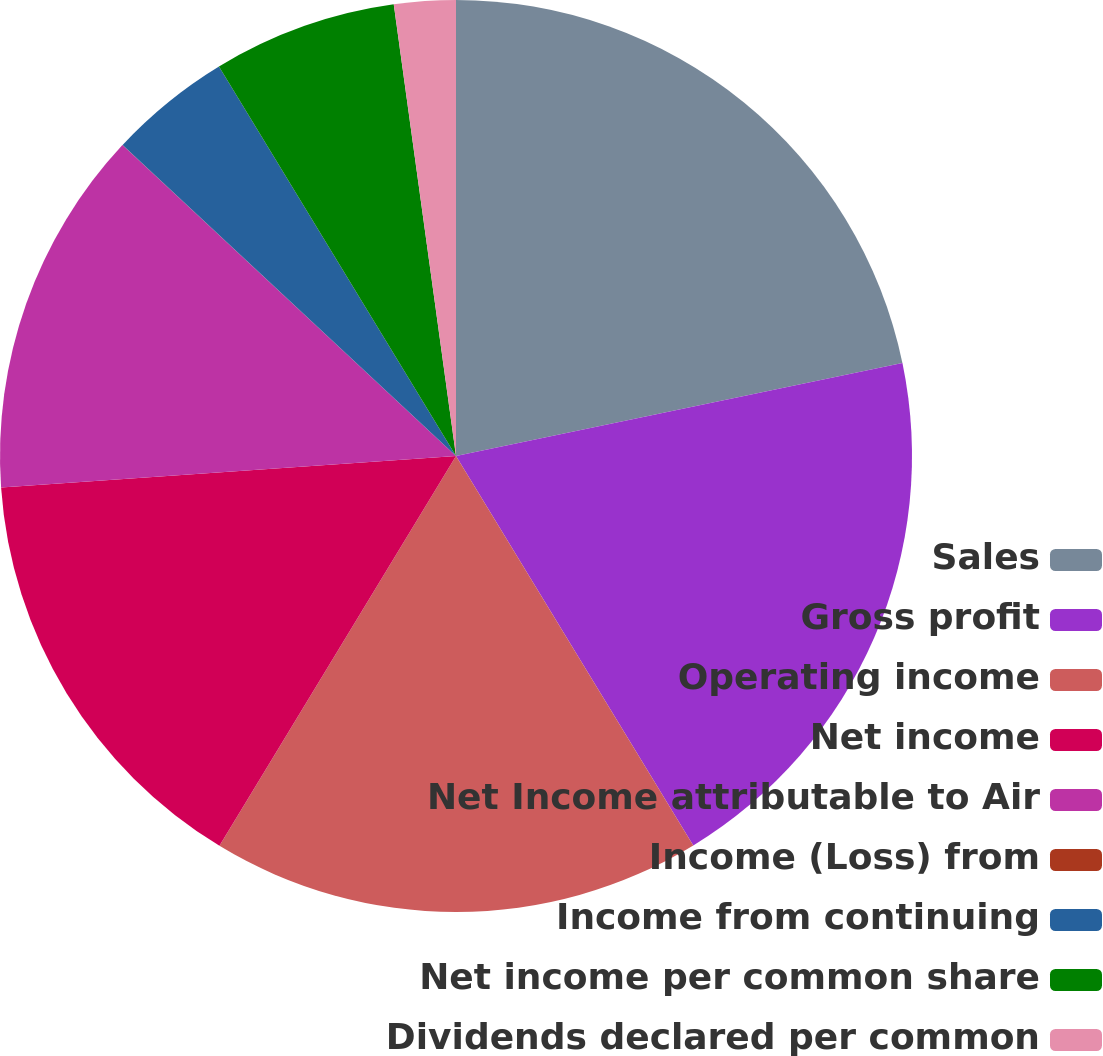<chart> <loc_0><loc_0><loc_500><loc_500><pie_chart><fcel>Sales<fcel>Gross profit<fcel>Operating income<fcel>Net income<fcel>Net Income attributable to Air<fcel>Income (Loss) from<fcel>Income from continuing<fcel>Net income per common share<fcel>Dividends declared per common<nl><fcel>21.73%<fcel>19.56%<fcel>17.39%<fcel>15.22%<fcel>13.04%<fcel>0.01%<fcel>4.35%<fcel>6.52%<fcel>2.18%<nl></chart> 